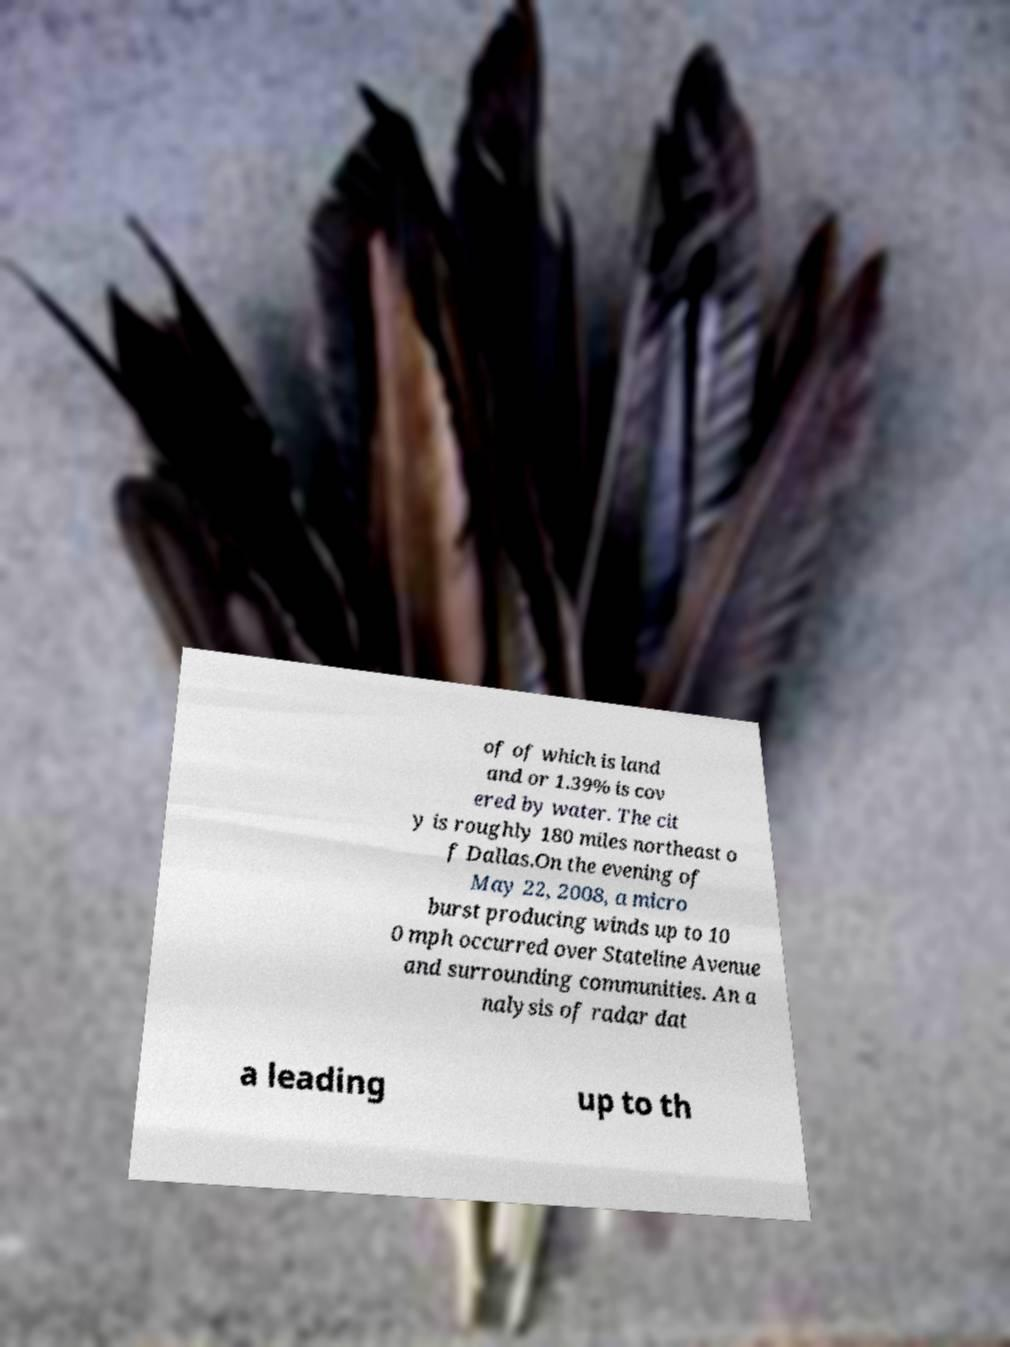Please read and relay the text visible in this image. What does it say? of of which is land and or 1.39% is cov ered by water. The cit y is roughly 180 miles northeast o f Dallas.On the evening of May 22, 2008, a micro burst producing winds up to 10 0 mph occurred over Stateline Avenue and surrounding communities. An a nalysis of radar dat a leading up to th 